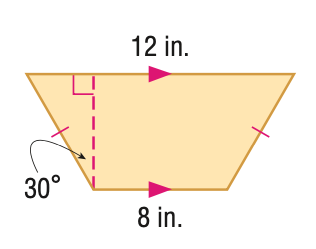Answer the mathemtical geometry problem and directly provide the correct option letter.
Question: Find the perimeter of the figure in feet. Round to the nearest tenth, if necessary.
Choices: A: 20 B: 28 C: 36 D: 44 B 